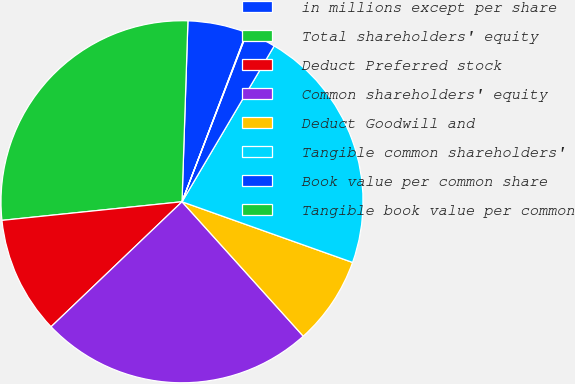<chart> <loc_0><loc_0><loc_500><loc_500><pie_chart><fcel>in millions except per share<fcel>Total shareholders' equity<fcel>Deduct Preferred stock<fcel>Common shareholders' equity<fcel>Deduct Goodwill and<fcel>Tangible common shareholders'<fcel>Book value per common share<fcel>Tangible book value per common<nl><fcel>5.27%<fcel>27.16%<fcel>10.49%<fcel>24.55%<fcel>7.88%<fcel>21.94%<fcel>2.66%<fcel>0.05%<nl></chart> 